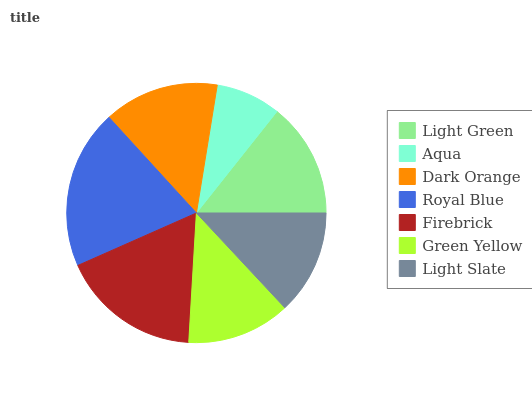Is Aqua the minimum?
Answer yes or no. Yes. Is Royal Blue the maximum?
Answer yes or no. Yes. Is Dark Orange the minimum?
Answer yes or no. No. Is Dark Orange the maximum?
Answer yes or no. No. Is Dark Orange greater than Aqua?
Answer yes or no. Yes. Is Aqua less than Dark Orange?
Answer yes or no. Yes. Is Aqua greater than Dark Orange?
Answer yes or no. No. Is Dark Orange less than Aqua?
Answer yes or no. No. Is Light Green the high median?
Answer yes or no. Yes. Is Light Green the low median?
Answer yes or no. Yes. Is Firebrick the high median?
Answer yes or no. No. Is Dark Orange the low median?
Answer yes or no. No. 